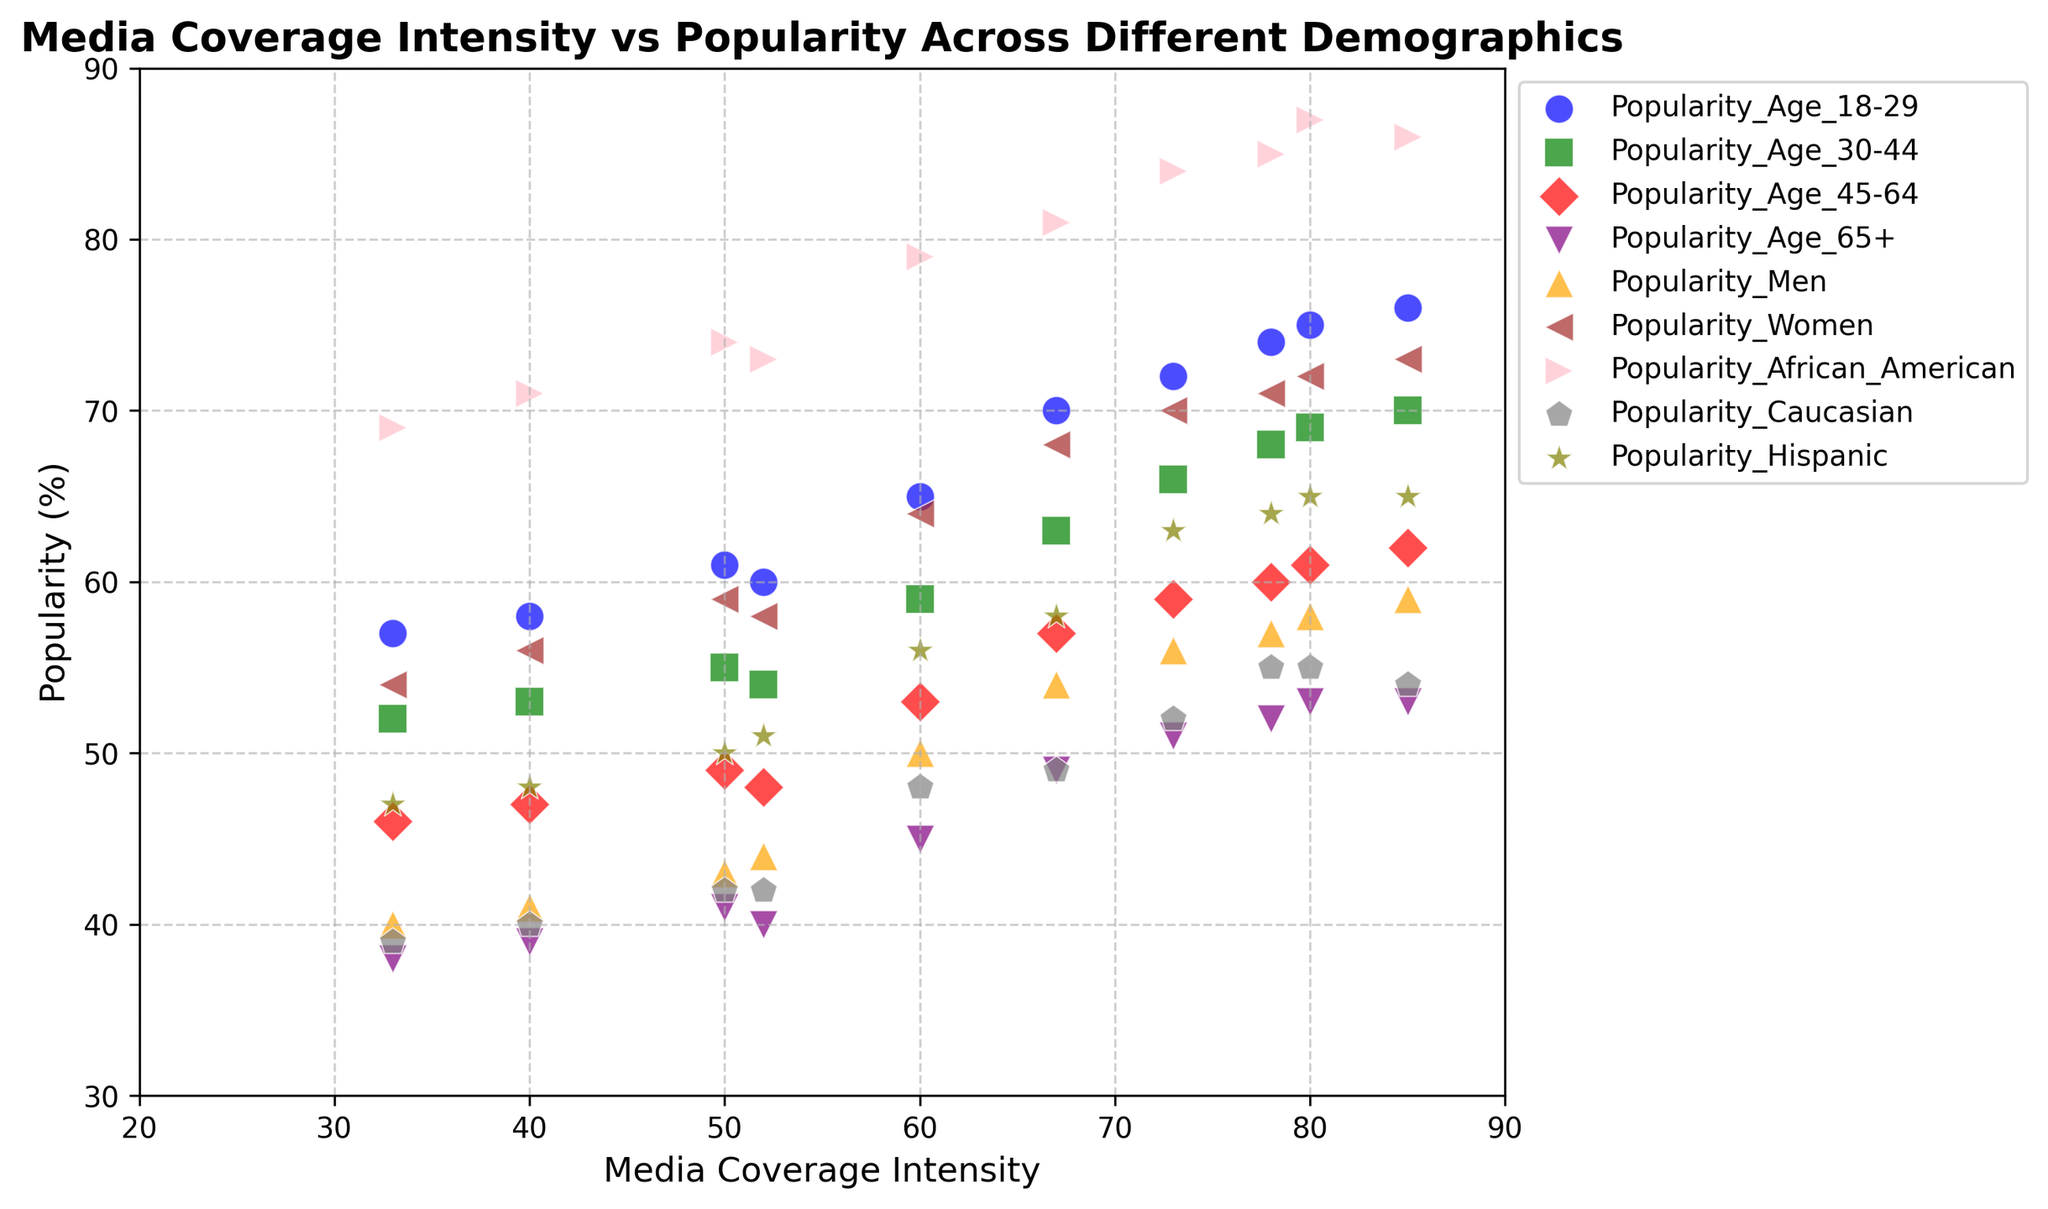what trend can you see in the popularity among African Americans as media coverage intensity increases? The points for the African American demographic increase as the media coverage intensity increases, indicating positive correlation. For instance, as coverage rises from 33 to 85, the popularity among African Americans rises from 69 to 86.
Answer: Positive trend Which demographic shows the least popularity at the highest media coverage intensity point? By looking at the highest media coverage intensity point of 85, Caucasian popularity shows the least value of 54 when compared to other demographics at this point.
Answer: Caucasian Is there a noticeable demographic group that has a consistent popularity value across different media coverage intensities? By comparing the points for each demographic group across the range of media coverage intensities, the Caucasian popularity has smaller variations ranging from 39 to 55, showing more consistency.
Answer: Caucasian How does the popularity among men and women compare at the media coverage intensity of 67? At a media coverage intensity of 67, the popularity among men is 54 and among women is 68, which shows that women have higher popularity than men for this data point.
Answer: Women have higher popularity Which demographic has the highest average popularity across all media coverage intensities? To find this, sum and average the values for each demographic across all points. African American has values: 74+81+86+71+84+73+85+69+79+87 = 790, over 10 points, average is 790/10 = 79. This is higher compared to the others.
Answer: African American What is the difference in popularity between the age group 30-44 and 65+ at a media coverage intensity of 78? At media coverage intensity 78, the popularity for age 30-44 is 68 and for age 65+ is 52. The difference is found by subtracting the latter from the former: 68 - 52 = 16.
Answer: 16 At which media coverage intensity does the Hispanic demographic reach its minimum popularity, and what is that value? By examining the scatter points for the Hispanic demographic, the minimum popularity value is 47 at a media coverage intensity of 33.
Answer: 33, 47 What can you infer about the trend in popularity among the age group 18-29 with increasing media coverage intensity? The scatter points for the 18-29 age group generally trend upward with increasing media coverage intensity, suggesting a positive correlation. For example, as coverage increases from 33 to 85, the popularity increases from 57 to 76.
Answer: Positive trend Considering the data points, does higher media coverage intensity seem to positively impact the popularity among older age groups (45-64 and 65+)? By observing the points for age groups 45-64 and 65+, both generally show a positive correlation with increased media coverage intensity. This is indicated by increasing popularity values as media coverage rises.
Answer: Yes, positive impact What is the approximate range in popularity values for the demographic group aged 30-44? By observing the scatter points for the 30-44 age group, the values range from a minimum of 52 to a maximum of 76. Therefore, the range is 76 - 52 = 24.
Answer: 24 